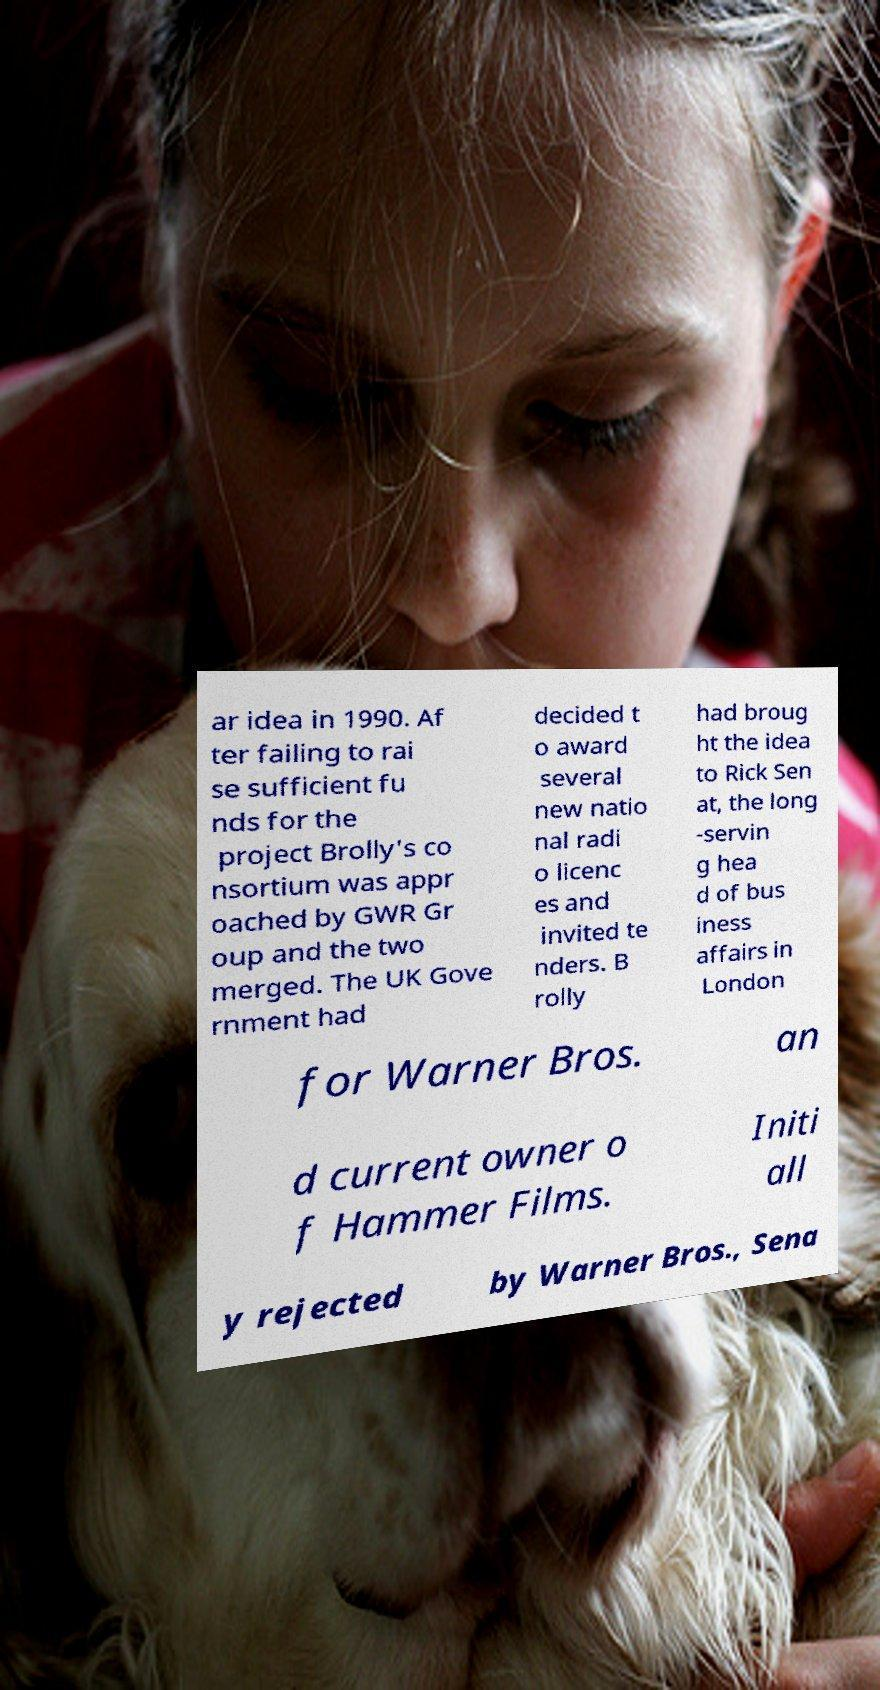There's text embedded in this image that I need extracted. Can you transcribe it verbatim? ar idea in 1990. Af ter failing to rai se sufficient fu nds for the project Brolly's co nsortium was appr oached by GWR Gr oup and the two merged. The UK Gove rnment had decided t o award several new natio nal radi o licenc es and invited te nders. B rolly had broug ht the idea to Rick Sen at, the long -servin g hea d of bus iness affairs in London for Warner Bros. an d current owner o f Hammer Films. Initi all y rejected by Warner Bros., Sena 